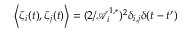<formula> <loc_0><loc_0><loc_500><loc_500>\left \langle \zeta _ { i } ( t ) , \zeta _ { j } ( t ) \right \rangle = ( 2 / \mathcal { A } _ { i } ^ { 1 , * } ) ^ { 2 } \delta _ { i , j } \delta ( t - t ^ { \prime } )</formula> 